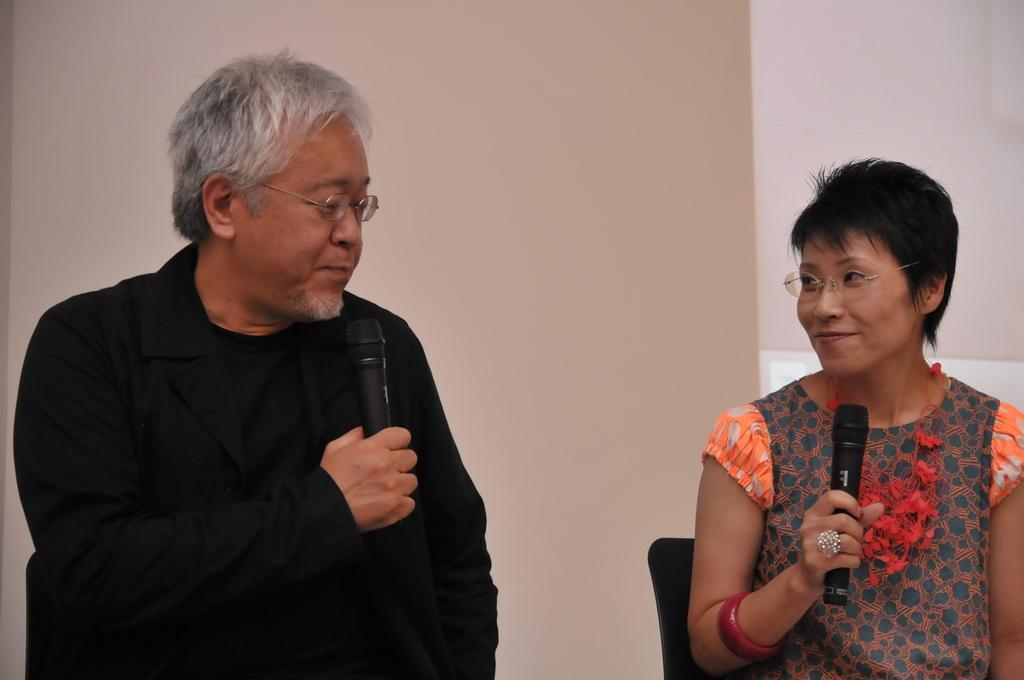Can you describe this image briefly? These two persons are sitting on the chairs and holding microphones and wear glasses. On the background we can see wall. 